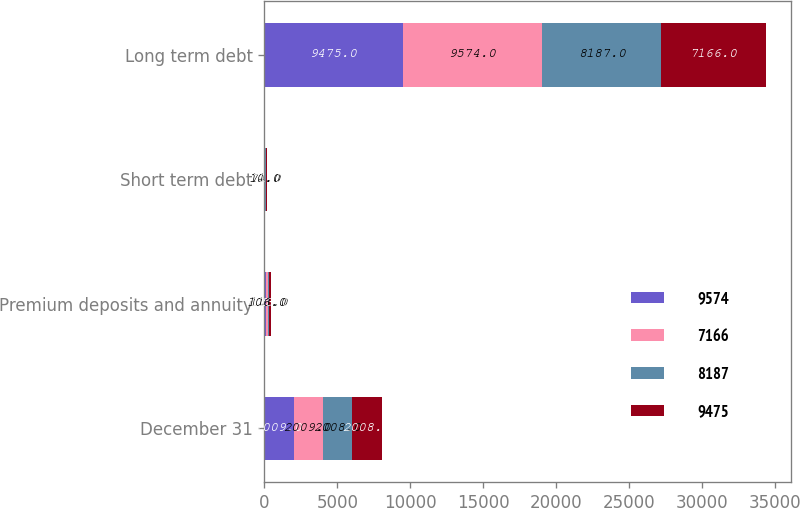<chart> <loc_0><loc_0><loc_500><loc_500><stacked_bar_chart><ecel><fcel>December 31<fcel>Premium deposits and annuity<fcel>Short term debt<fcel>Long term debt<nl><fcel>9574<fcel>2009<fcel>105<fcel>10<fcel>9475<nl><fcel>7166<fcel>2009<fcel>106<fcel>10<fcel>9574<nl><fcel>8187<fcel>2008<fcel>111<fcel>71<fcel>8187<nl><fcel>9475<fcel>2008<fcel>113<fcel>71<fcel>7166<nl></chart> 